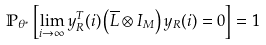<formula> <loc_0><loc_0><loc_500><loc_500>\mathbb { P } _ { \theta ^ { \ast } } \left [ \lim _ { i \rightarrow \infty } y _ { R } ^ { T } ( i ) \left ( \overline { L } \otimes I _ { M } \right ) y _ { R } ( i ) = 0 \right ] = 1</formula> 